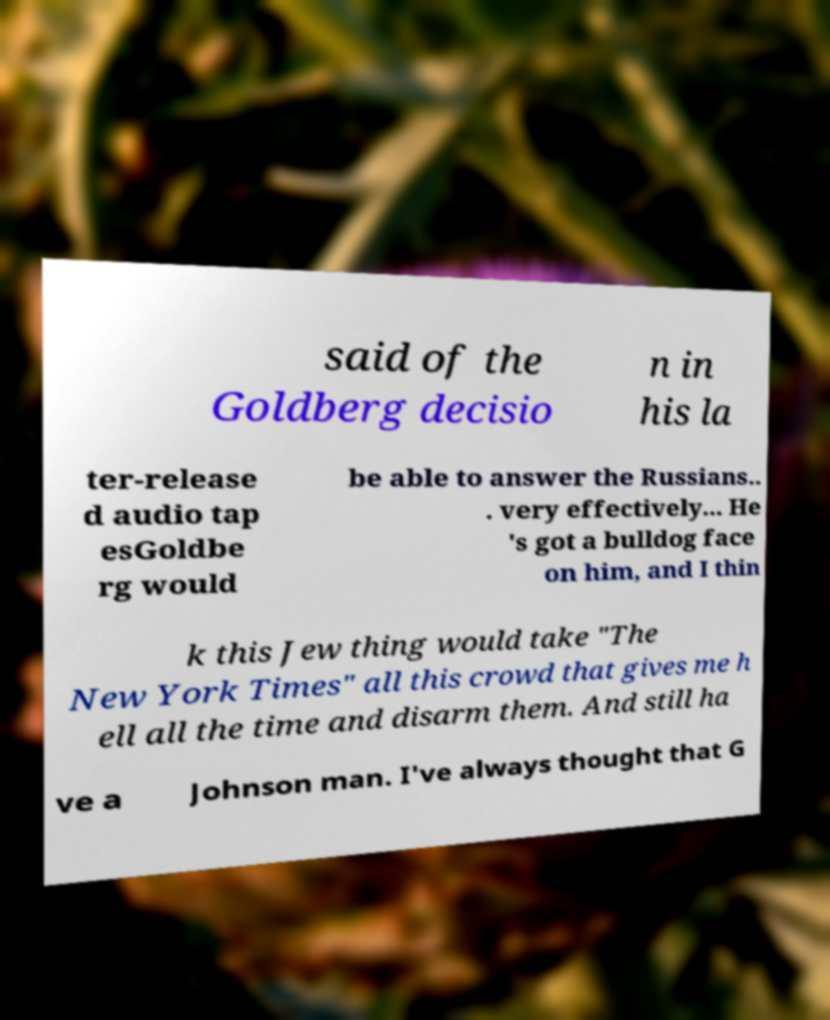What messages or text are displayed in this image? I need them in a readable, typed format. said of the Goldberg decisio n in his la ter-release d audio tap esGoldbe rg would be able to answer the Russians.. . very effectively... He 's got a bulldog face on him, and I thin k this Jew thing would take "The New York Times" all this crowd that gives me h ell all the time and disarm them. And still ha ve a Johnson man. I've always thought that G 